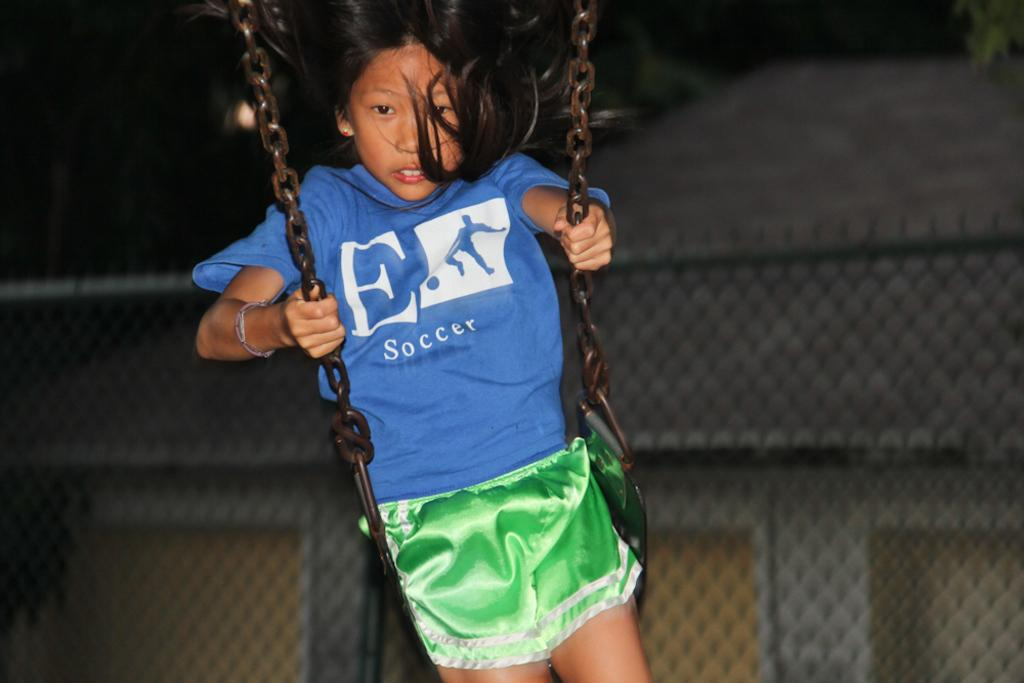<image>
Offer a succinct explanation of the picture presented. A girl is swinging with a shirt on that has the word soccer on it. 